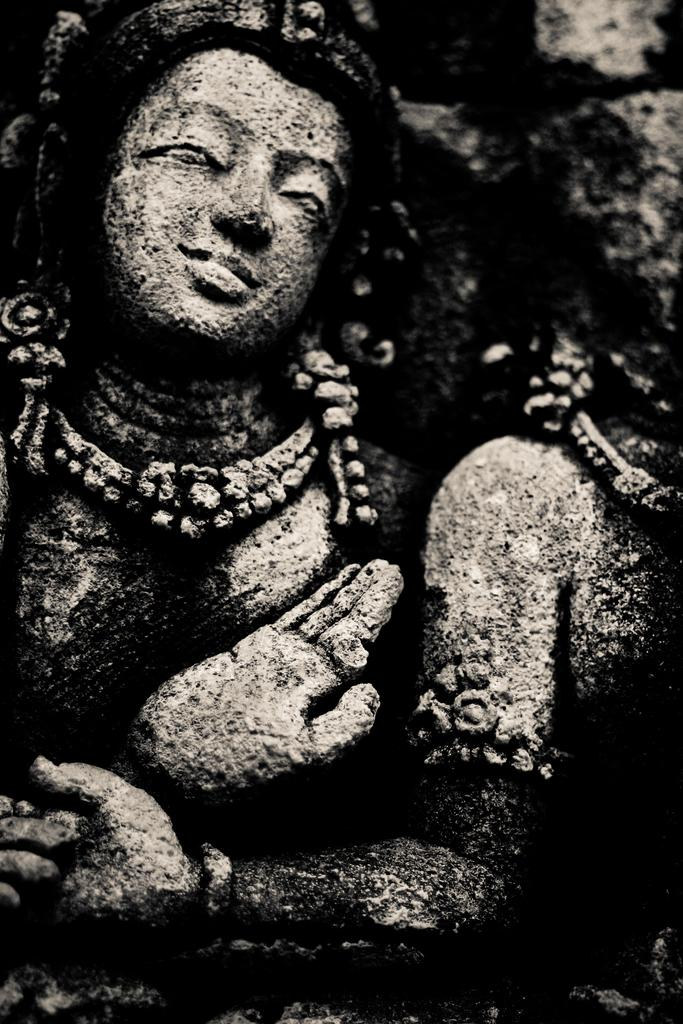What is the color scheme of the picture? The picture is black and white. What can be seen in the picture? There is a sculpture in the picture. What type of popcorn is being served at the mine in the image? There is no mention of popcorn, a mine, or any serving in the image. The image only features a black and white sculpture. 